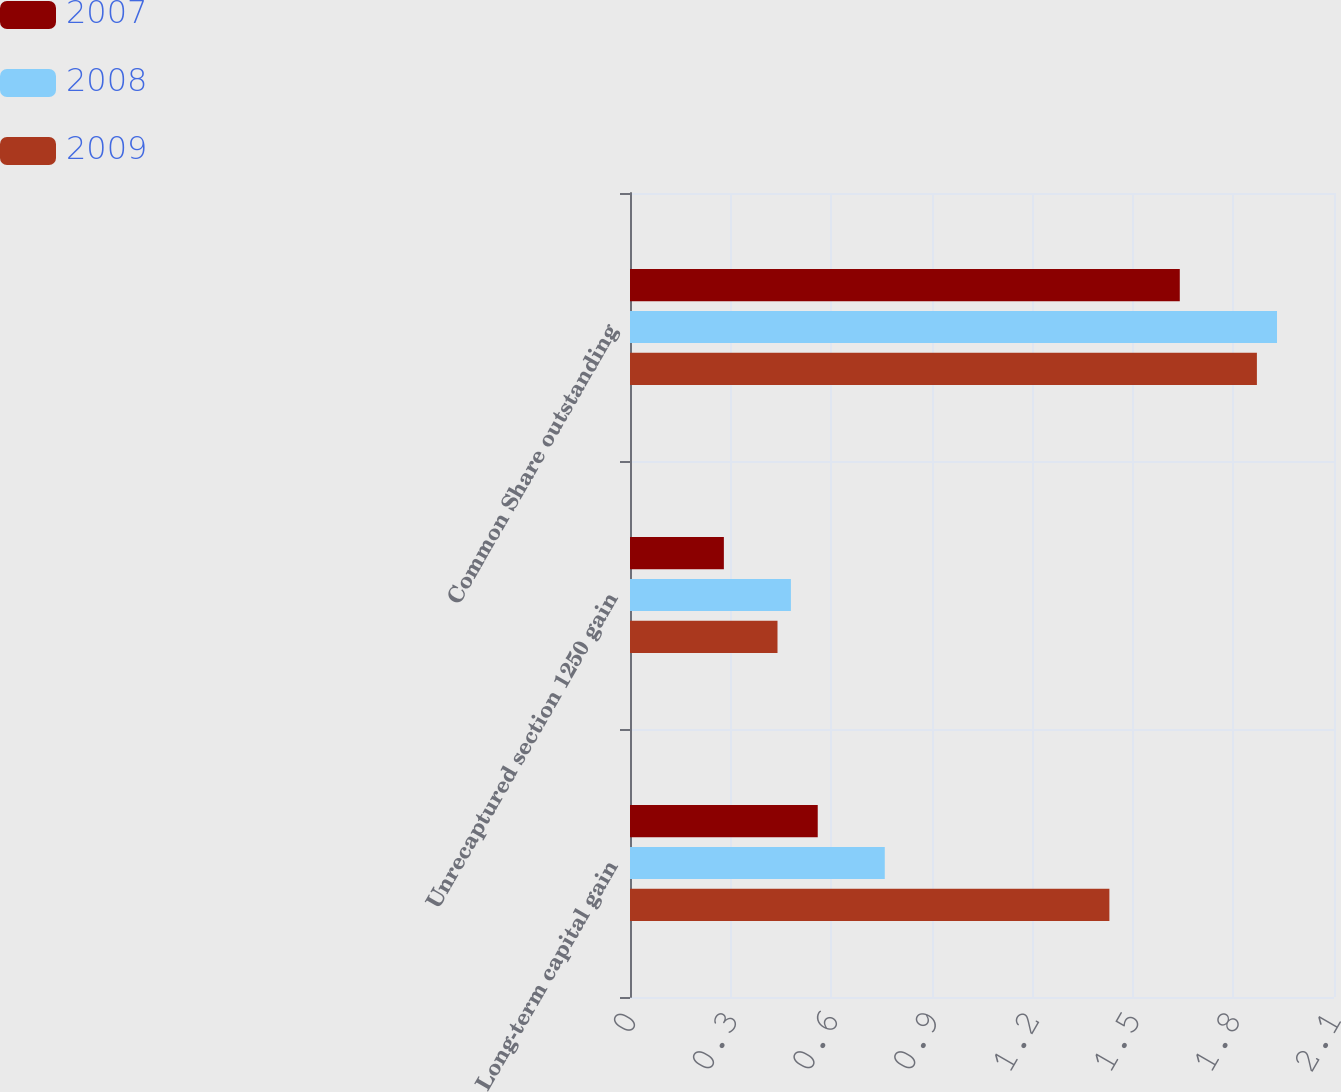Convert chart. <chart><loc_0><loc_0><loc_500><loc_500><stacked_bar_chart><ecel><fcel>Long-term capital gain<fcel>Unrecaptured section 1250 gain<fcel>Common Share outstanding<nl><fcel>2007<fcel>0.56<fcel>0.28<fcel>1.64<nl><fcel>2008<fcel>0.76<fcel>0.48<fcel>1.93<nl><fcel>2009<fcel>1.43<fcel>0.44<fcel>1.87<nl></chart> 